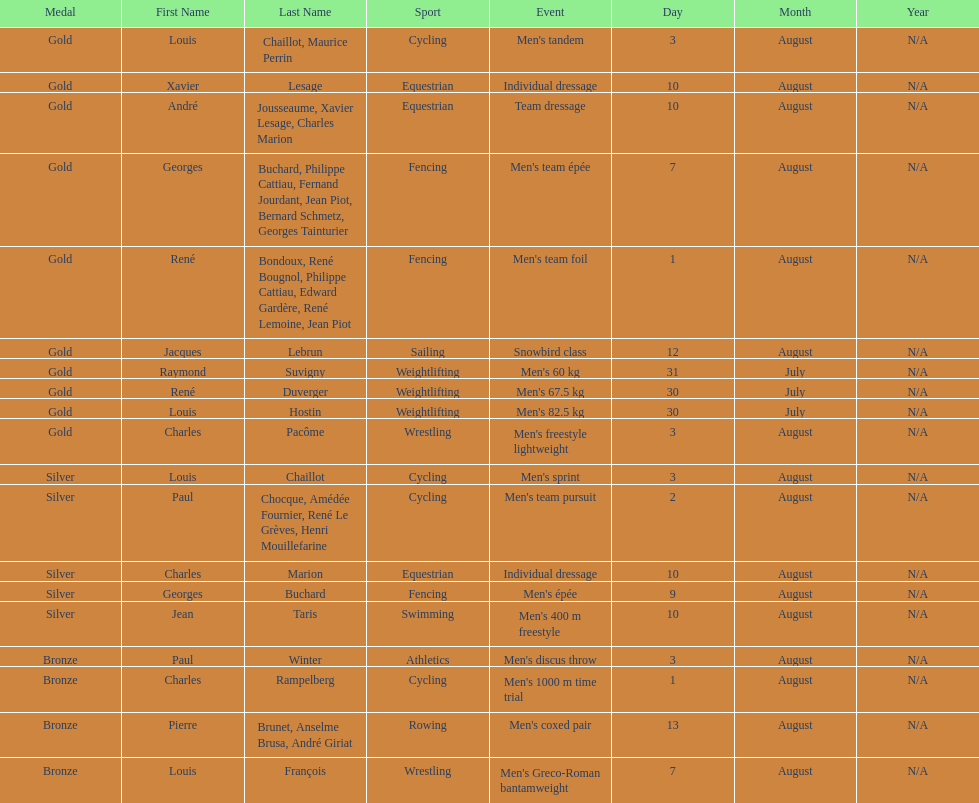What is next date that is listed after august 7th? August 1. 